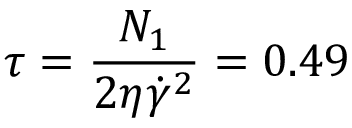Convert formula to latex. <formula><loc_0><loc_0><loc_500><loc_500>\tau = \frac { N _ { 1 } } { 2 \eta \dot { \gamma } ^ { 2 } } = 0 . 4 9</formula> 